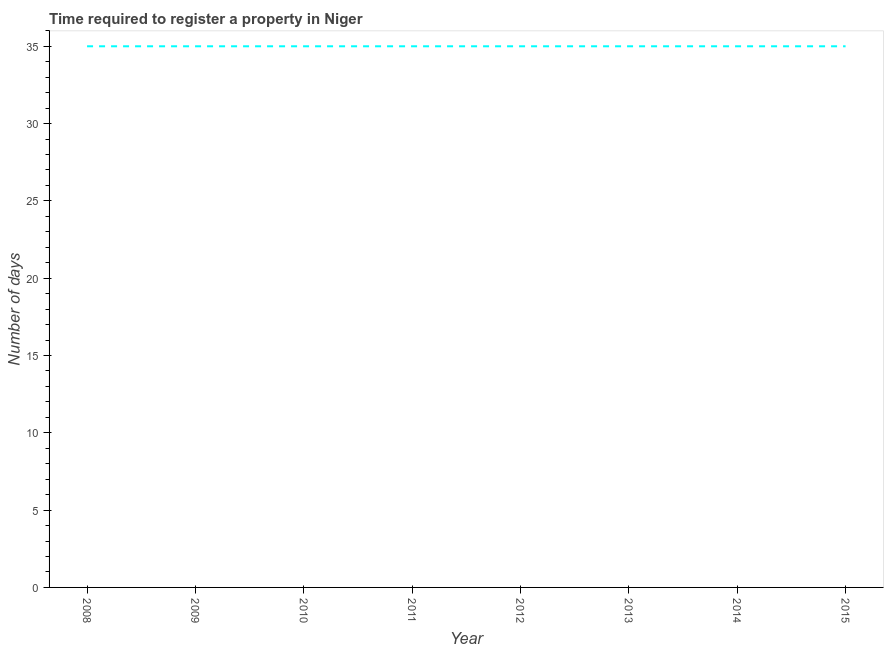What is the number of days required to register property in 2014?
Make the answer very short. 35. Across all years, what is the maximum number of days required to register property?
Your answer should be very brief. 35. Across all years, what is the minimum number of days required to register property?
Offer a terse response. 35. In which year was the number of days required to register property minimum?
Give a very brief answer. 2008. What is the sum of the number of days required to register property?
Provide a succinct answer. 280. What is the average number of days required to register property per year?
Your answer should be compact. 35. What is the median number of days required to register property?
Your answer should be compact. 35. Is the number of days required to register property in 2009 less than that in 2014?
Your answer should be compact. No. Is the difference between the number of days required to register property in 2009 and 2011 greater than the difference between any two years?
Offer a terse response. Yes. What is the difference between the highest and the second highest number of days required to register property?
Make the answer very short. 0. Is the sum of the number of days required to register property in 2013 and 2014 greater than the maximum number of days required to register property across all years?
Your answer should be very brief. Yes. What is the difference between the highest and the lowest number of days required to register property?
Offer a very short reply. 0. Does the number of days required to register property monotonically increase over the years?
Provide a short and direct response. No. How many lines are there?
Offer a very short reply. 1. How many years are there in the graph?
Keep it short and to the point. 8. Are the values on the major ticks of Y-axis written in scientific E-notation?
Give a very brief answer. No. Does the graph contain grids?
Keep it short and to the point. No. What is the title of the graph?
Give a very brief answer. Time required to register a property in Niger. What is the label or title of the Y-axis?
Offer a very short reply. Number of days. What is the Number of days in 2008?
Your response must be concise. 35. What is the Number of days in 2012?
Offer a terse response. 35. What is the Number of days in 2015?
Your answer should be compact. 35. What is the difference between the Number of days in 2008 and 2009?
Your answer should be very brief. 0. What is the difference between the Number of days in 2008 and 2010?
Your response must be concise. 0. What is the difference between the Number of days in 2008 and 2013?
Your answer should be very brief. 0. What is the difference between the Number of days in 2008 and 2015?
Give a very brief answer. 0. What is the difference between the Number of days in 2009 and 2010?
Offer a terse response. 0. What is the difference between the Number of days in 2009 and 2012?
Offer a terse response. 0. What is the difference between the Number of days in 2009 and 2013?
Offer a terse response. 0. What is the difference between the Number of days in 2009 and 2014?
Give a very brief answer. 0. What is the difference between the Number of days in 2010 and 2011?
Offer a very short reply. 0. What is the difference between the Number of days in 2010 and 2014?
Your response must be concise. 0. What is the difference between the Number of days in 2010 and 2015?
Keep it short and to the point. 0. What is the difference between the Number of days in 2011 and 2012?
Provide a succinct answer. 0. What is the difference between the Number of days in 2011 and 2014?
Keep it short and to the point. 0. What is the ratio of the Number of days in 2008 to that in 2009?
Ensure brevity in your answer.  1. What is the ratio of the Number of days in 2008 to that in 2011?
Provide a succinct answer. 1. What is the ratio of the Number of days in 2009 to that in 2010?
Your answer should be very brief. 1. What is the ratio of the Number of days in 2009 to that in 2011?
Give a very brief answer. 1. What is the ratio of the Number of days in 2009 to that in 2012?
Offer a very short reply. 1. What is the ratio of the Number of days in 2010 to that in 2011?
Your answer should be very brief. 1. What is the ratio of the Number of days in 2011 to that in 2012?
Keep it short and to the point. 1. What is the ratio of the Number of days in 2011 to that in 2014?
Your answer should be very brief. 1. What is the ratio of the Number of days in 2011 to that in 2015?
Make the answer very short. 1. What is the ratio of the Number of days in 2012 to that in 2013?
Ensure brevity in your answer.  1. What is the ratio of the Number of days in 2012 to that in 2014?
Make the answer very short. 1. What is the ratio of the Number of days in 2013 to that in 2014?
Provide a succinct answer. 1. 